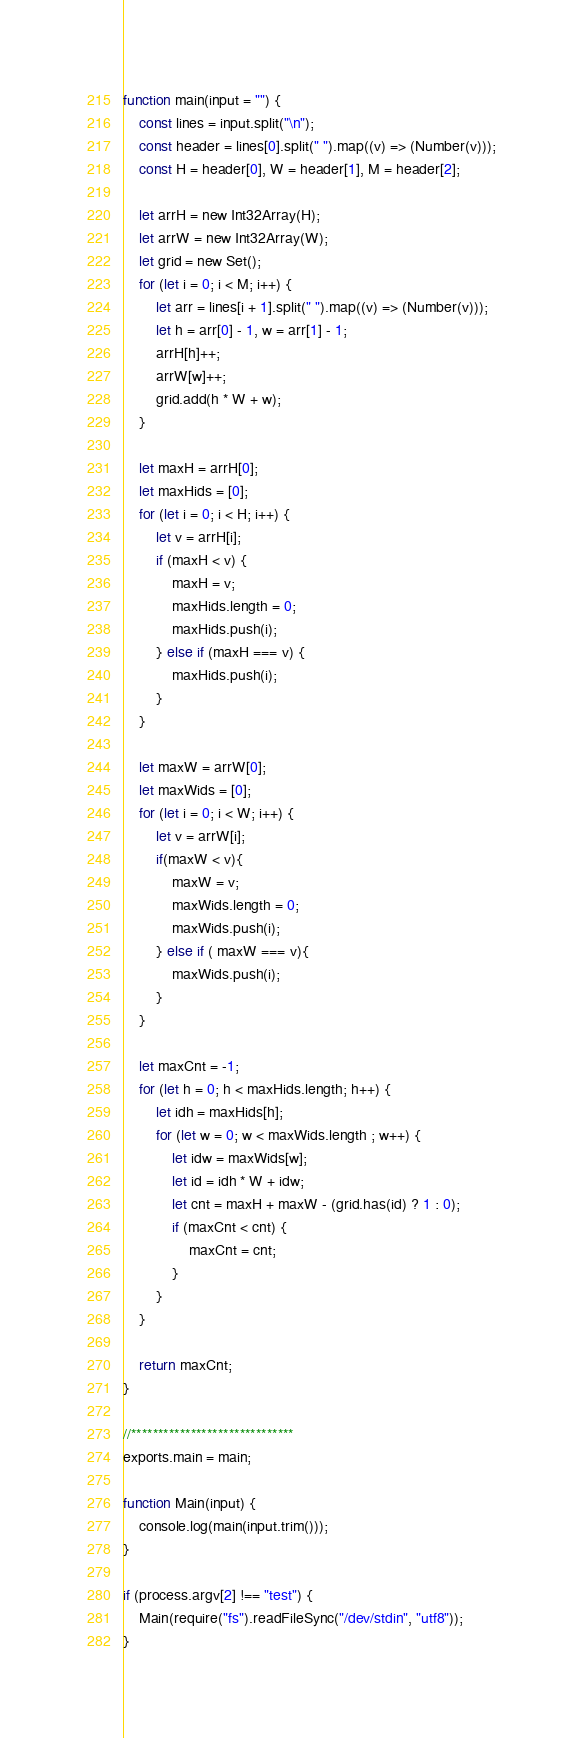Convert code to text. <code><loc_0><loc_0><loc_500><loc_500><_JavaScript_>function main(input = "") {
    const lines = input.split("\n");
    const header = lines[0].split(" ").map((v) => (Number(v)));
    const H = header[0], W = header[1], M = header[2];

    let arrH = new Int32Array(H);
    let arrW = new Int32Array(W);
    let grid = new Set();
    for (let i = 0; i < M; i++) {
        let arr = lines[i + 1].split(" ").map((v) => (Number(v)));
        let h = arr[0] - 1, w = arr[1] - 1;
        arrH[h]++;
        arrW[w]++;
        grid.add(h * W + w);
    }

    let maxH = arrH[0];
    let maxHids = [0];
    for (let i = 0; i < H; i++) {
        let v = arrH[i];
        if (maxH < v) {
            maxH = v;
            maxHids.length = 0;
            maxHids.push(i);
        } else if (maxH === v) {
            maxHids.push(i);
        }
    }

    let maxW = arrW[0];
    let maxWids = [0];
    for (let i = 0; i < W; i++) {
        let v = arrW[i];
        if(maxW < v){
            maxW = v;
            maxWids.length = 0;
            maxWids.push(i);
        } else if ( maxW === v){
            maxWids.push(i);
        }
    }

    let maxCnt = -1;
    for (let h = 0; h < maxHids.length; h++) {
        let idh = maxHids[h];
        for (let w = 0; w < maxWids.length ; w++) {
            let idw = maxWids[w];
            let id = idh * W + idw;
            let cnt = maxH + maxW - (grid.has(id) ? 1 : 0);
            if (maxCnt < cnt) {
                maxCnt = cnt;
            }
        }
    }

    return maxCnt;
}

//******************************
exports.main = main;

function Main(input) {
    console.log(main(input.trim()));
}

if (process.argv[2] !== "test") {
    Main(require("fs").readFileSync("/dev/stdin", "utf8"));
}</code> 